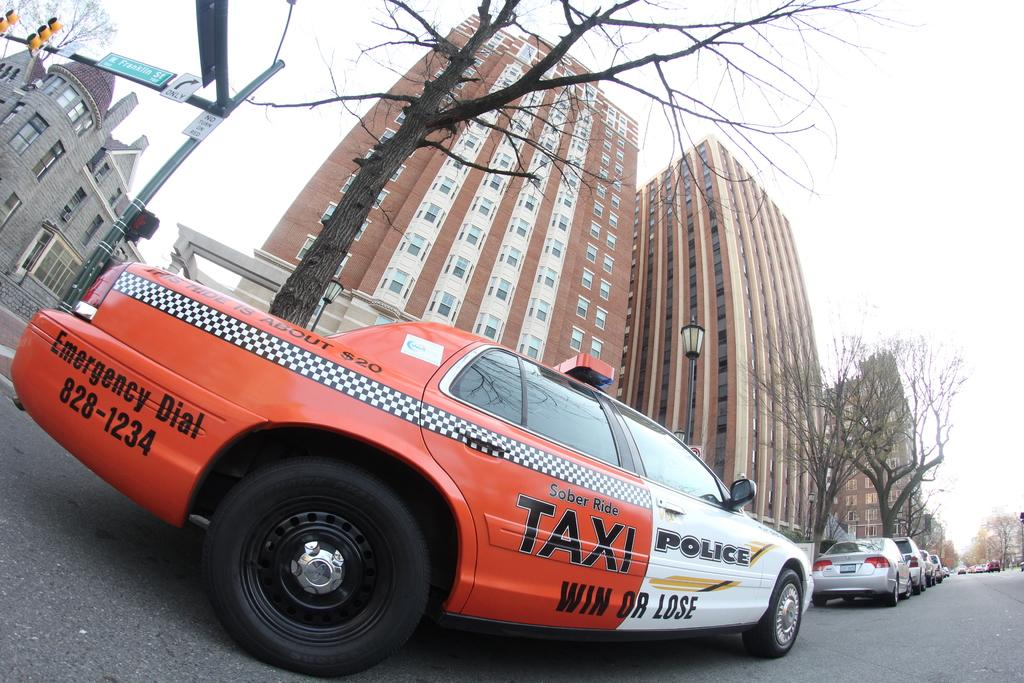<image>
Provide a brief description of the given image. A red and white combination Taxi and Police vehicle on a street. 